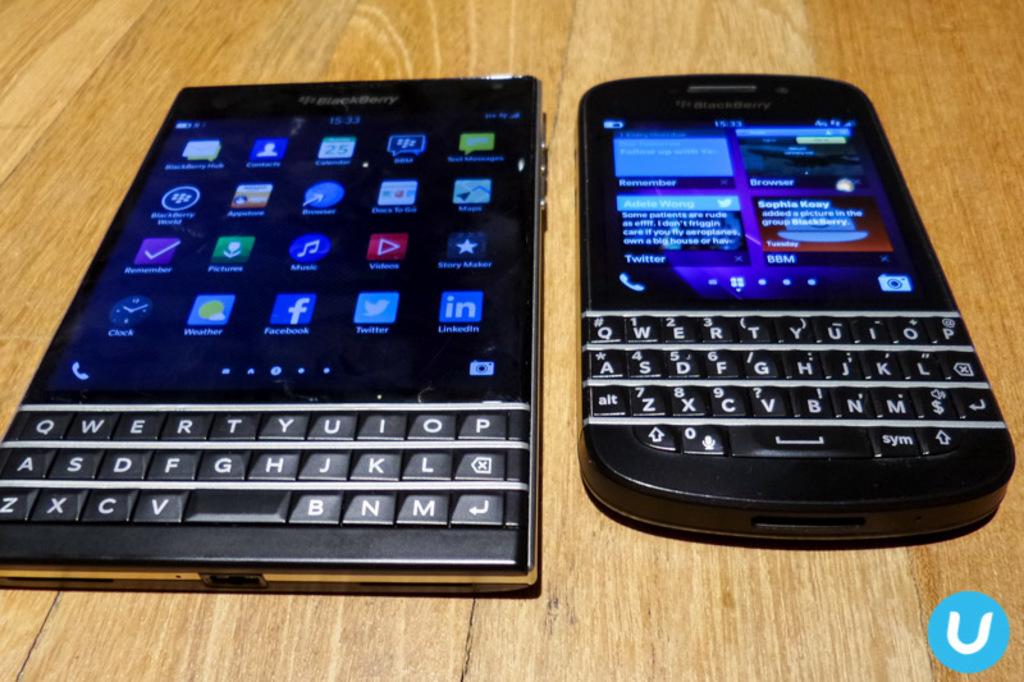What is the brand that made these phones?
Your response must be concise. Blackberry. Which app is represented by the letter "f"?
Provide a succinct answer. Facebook. 